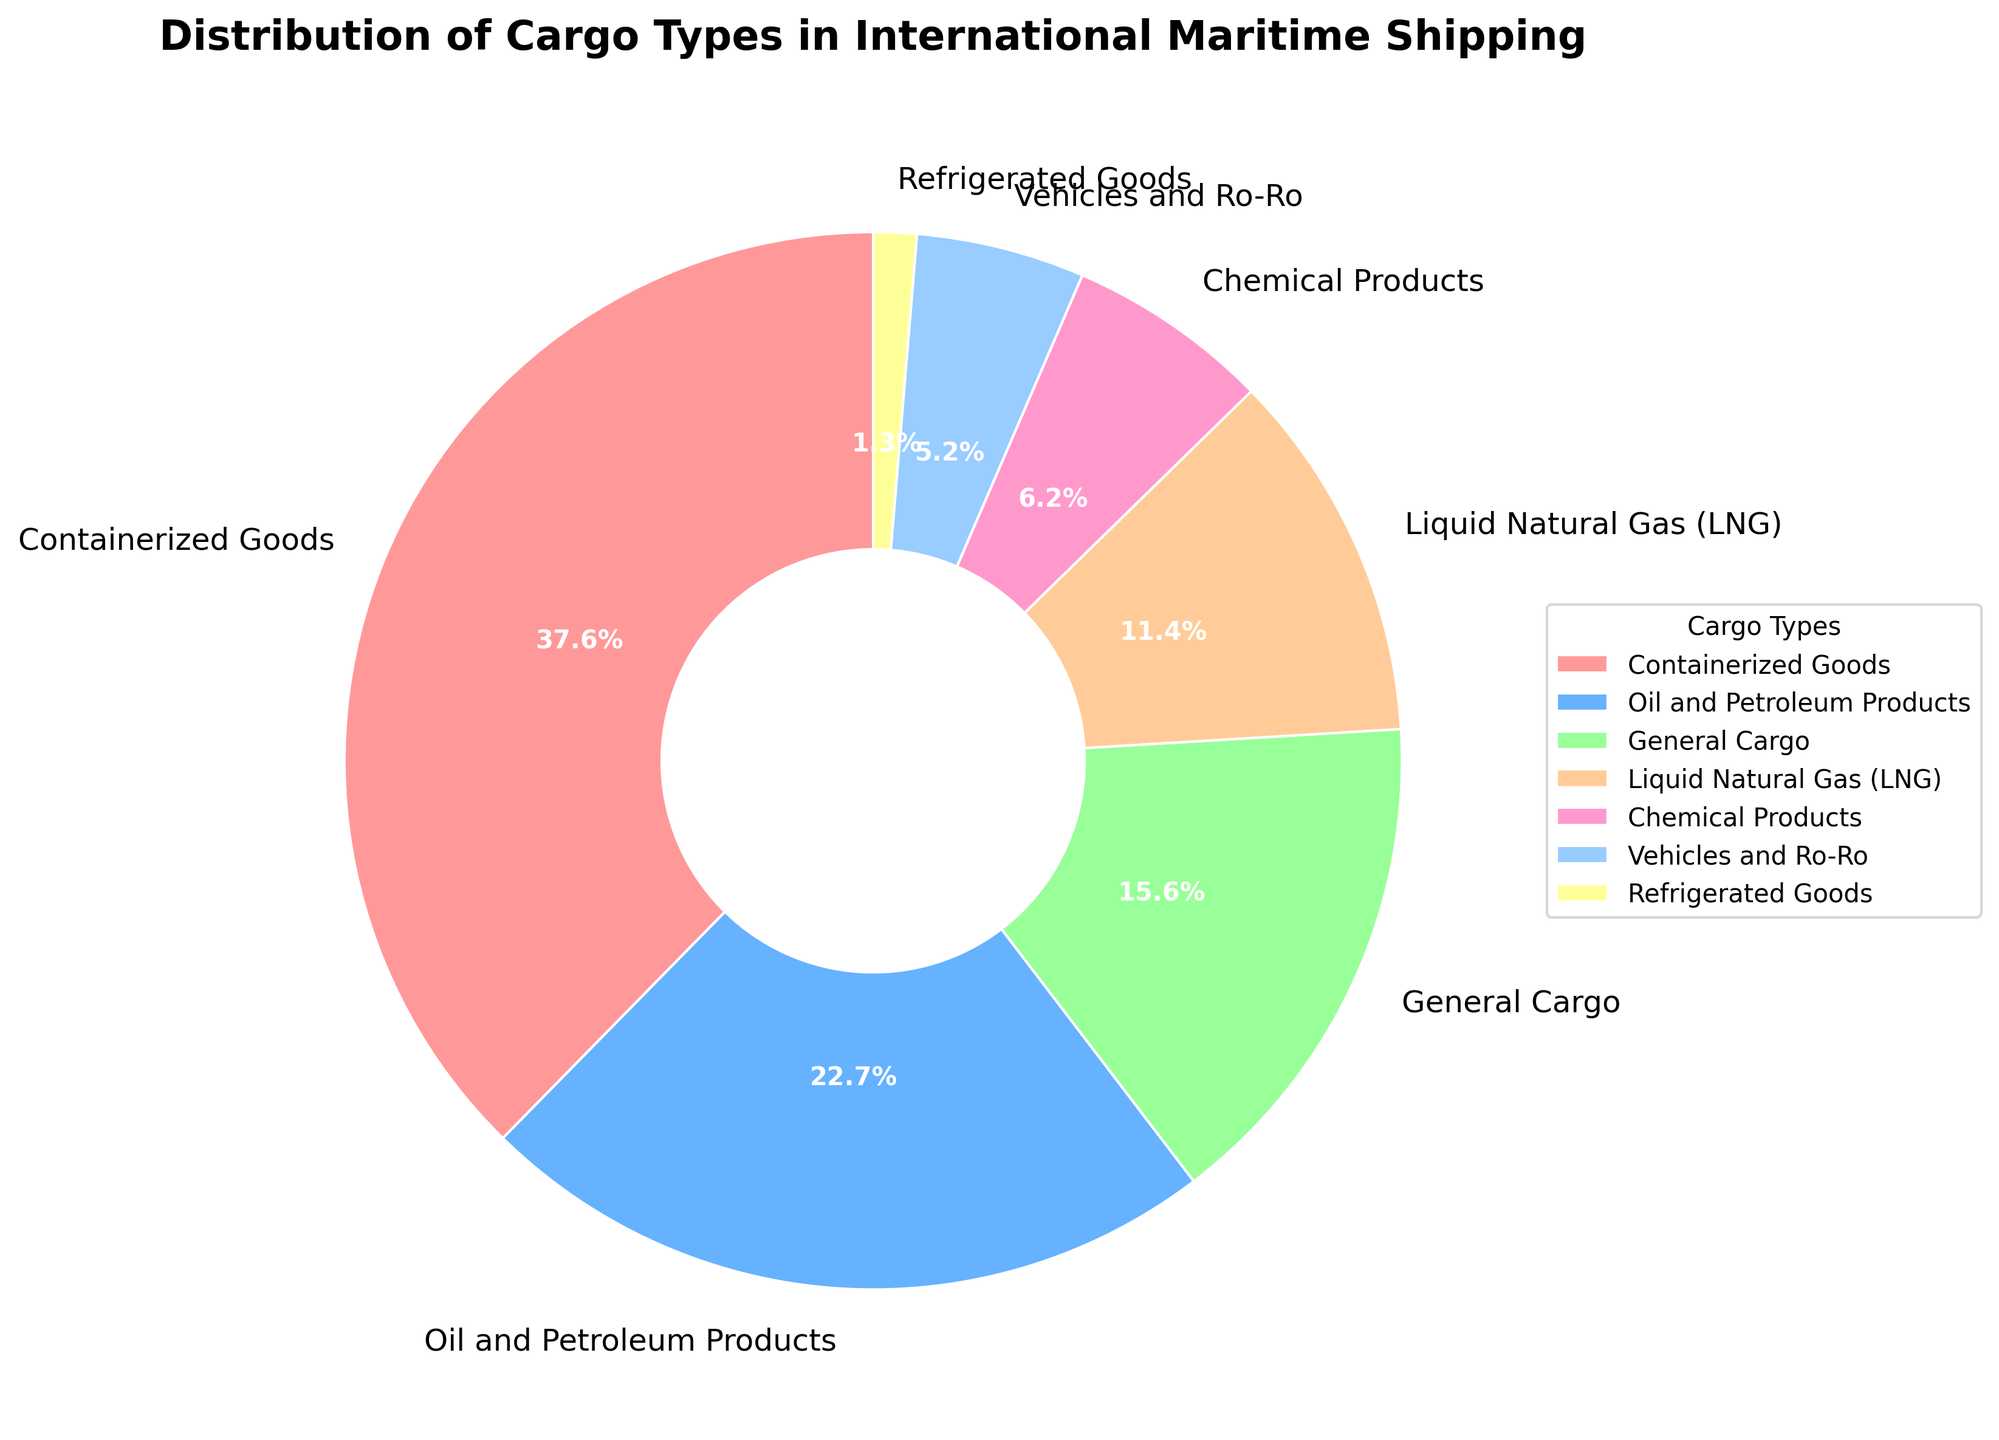What percentage of cargo types in international maritime shipping is made up of Oil and Petroleum Products and Chemical Products combined? Add the percentages of Oil and Petroleum Products (17.2%) and Chemical Products (4.7%). 17.2 + 4.7 = 21.9
Answer: 21.9% Which cargo type has the smallest percentage? Check the pie chart for the smallest slice. Refrigerated Goods has the smallest percentage at 1.0%.
Answer: Refrigerated Goods Are Containerized Goods more than twice the percentage of Oil and Petroleum Products? Compare Containerized Goods (28.5%) and double Oil and Petroleum Products (17.2% * 2 = 34.4). 28.5 is not greater than 34.4
Answer: No What is the approximate difference between the percentages of General Cargo and Vehicles and Ro-Ro? Subtract the percentage of Vehicles and Ro-Ro (3.9%) from General Cargo (11.8%). 11.8 - 3.9 = 7.9
Answer: 7.9 Which cargo type has the largest percentage and what is its value? Look for the largest slice in the pie chart. Containerized Goods has the largest percentage at 28.5%.
Answer: Containerized Goods, 28.5% Is the total percentage of Liquid Natural Gas (LNG) and Chemical Products more than 10%? Add the percentages of LNG (8.6%) and Chemical Products (4.7%). 8.6 + 4.7 = 13.3, which is more than 10%
Answer: Yes What color is the section representing General Cargo? Look at the pie chart and locate the color associated with General Cargo. General Cargo is represented by a color very close to the middle which is usually a specific color. In this case, it is typically visualized by a specific color which looks like light green.
Answer: Light green 